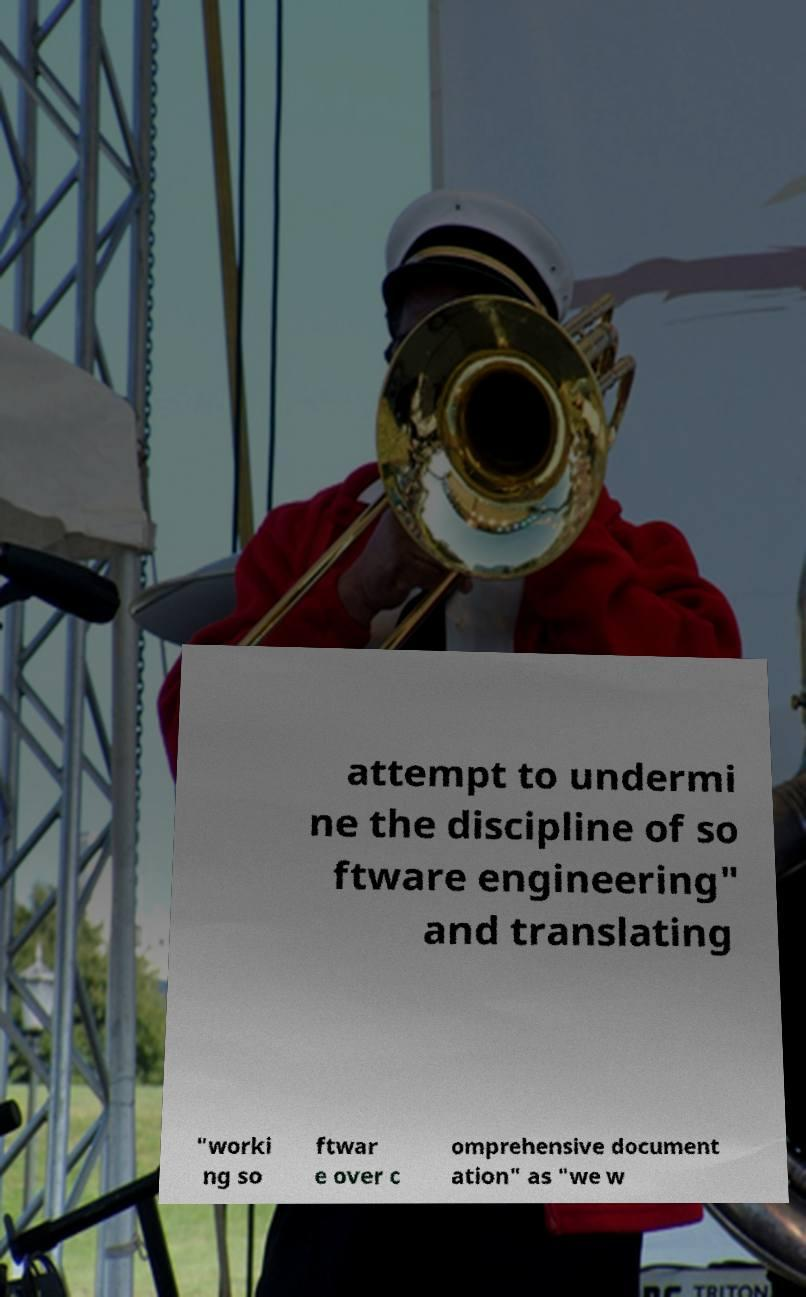Please read and relay the text visible in this image. What does it say? attempt to undermi ne the discipline of so ftware engineering" and translating "worki ng so ftwar e over c omprehensive document ation" as "we w 